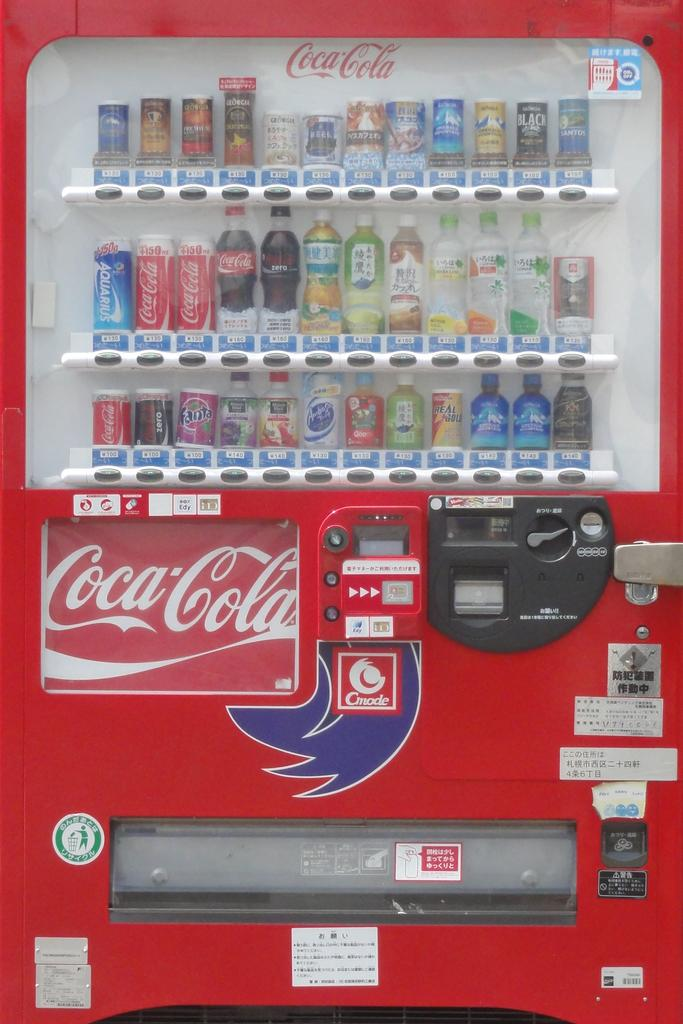<image>
Relay a brief, clear account of the picture shown. A Coca Cola vending machine with many drinks inside. 